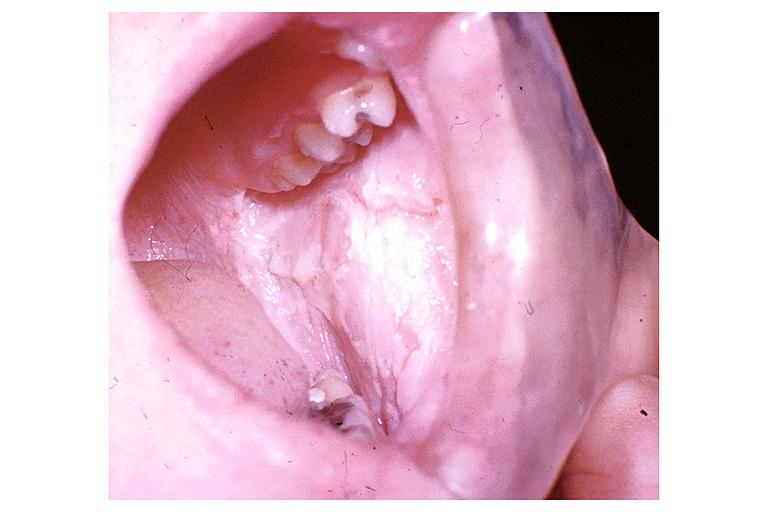what does this image show?
Answer the question using a single word or phrase. White sponge nevus 